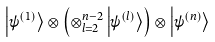<formula> <loc_0><loc_0><loc_500><loc_500>\left | \psi ^ { ( 1 ) } \right \rangle \otimes \left ( \otimes _ { l = 2 } ^ { n - 2 } \left | \psi ^ { ( l ) } \right \rangle \right ) \otimes \left | \psi ^ { ( n ) } \right \rangle</formula> 